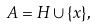<formula> <loc_0><loc_0><loc_500><loc_500>A = H \cup \{ x \} ,</formula> 